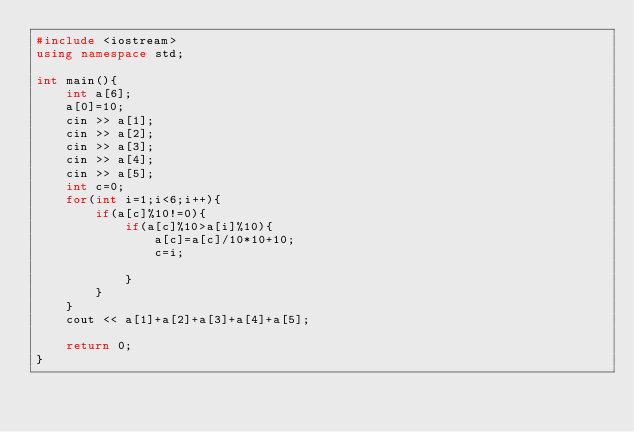Convert code to text. <code><loc_0><loc_0><loc_500><loc_500><_C++_>#include <iostream>
using namespace std;

int main(){
	int a[6];
	a[0]=10;
	cin >> a[1];
	cin >> a[2];
	cin >> a[3];
	cin >> a[4];
	cin >> a[5];
	int c=0;
	for(int i=1;i<6;i++){
		if(a[c]%10!=0){
			if(a[c]%10>a[i]%10){
				a[c]=a[c]/10*10+10;
				c=i;
				
			}
		}
	}
	cout << a[1]+a[2]+a[3]+a[4]+a[5];
	
	return 0;
}</code> 